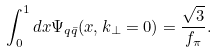<formula> <loc_0><loc_0><loc_500><loc_500>\int ^ { 1 } _ { 0 } d x \Psi _ { q \bar { q } } ( x , { k } _ { \perp } = 0 ) = \frac { \sqrt { 3 } } { f _ { \pi } } .</formula> 